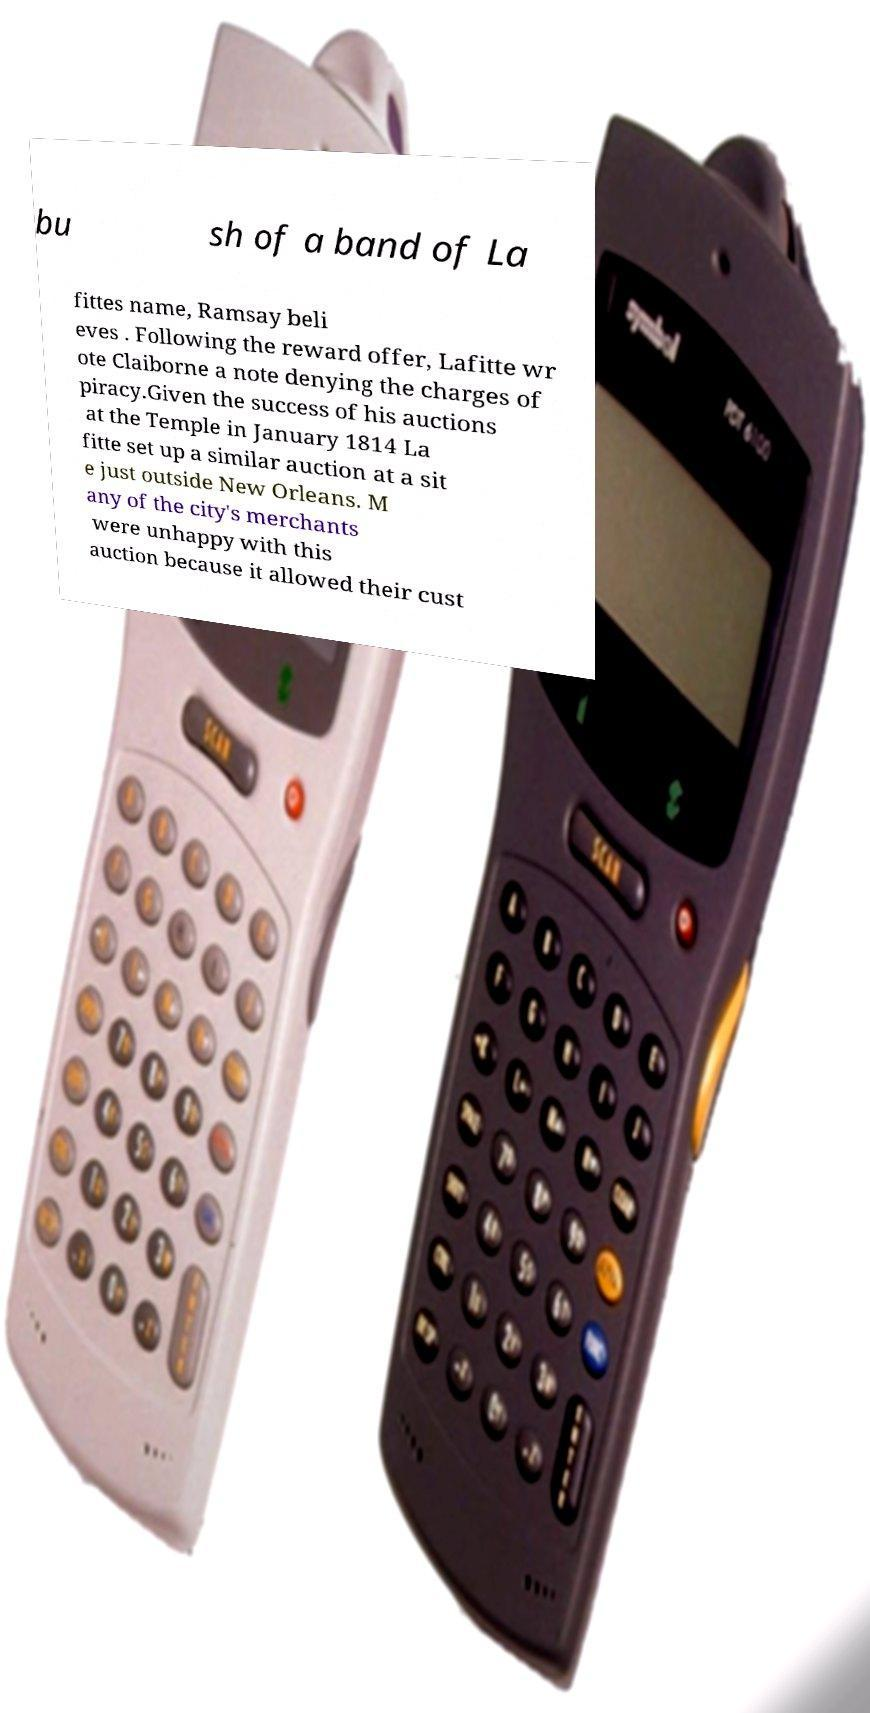Can you read and provide the text displayed in the image?This photo seems to have some interesting text. Can you extract and type it out for me? bu sh of a band of La fittes name, Ramsay beli eves . Following the reward offer, Lafitte wr ote Claiborne a note denying the charges of piracy.Given the success of his auctions at the Temple in January 1814 La fitte set up a similar auction at a sit e just outside New Orleans. M any of the city's merchants were unhappy with this auction because it allowed their cust 